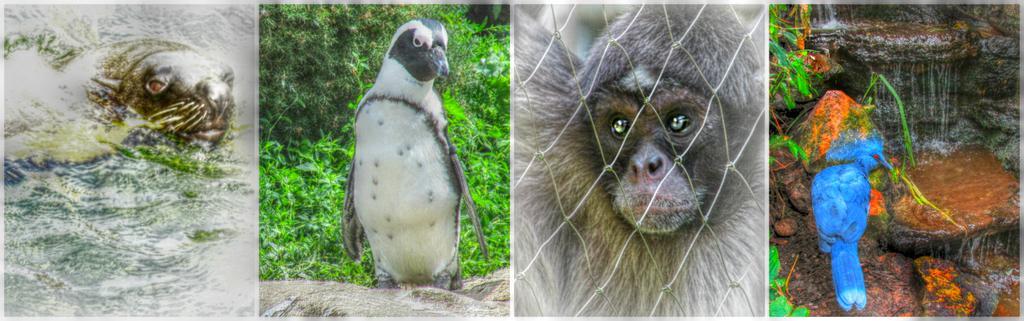Please provide a concise description of this image. In this picture I can see the collage image. I can see two birds and two animals. I can see water, plants, stones. I can see the metal grill fence. 